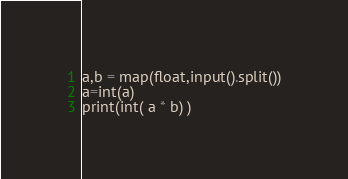<code> <loc_0><loc_0><loc_500><loc_500><_Python_>a,b = map(float,input().split())
a=int(a)
print(int( a * b) )</code> 